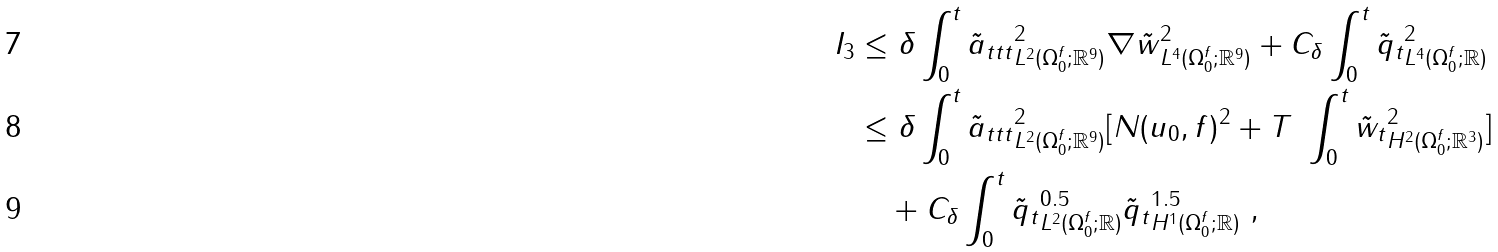Convert formula to latex. <formula><loc_0><loc_0><loc_500><loc_500>I _ { 3 } & \leq \delta \int _ { 0 } ^ { t } \| \tilde { a } _ { t t t } \| ^ { 2 } _ { L ^ { 2 } ( \Omega _ { 0 } ^ { f } ; { \mathbb { R } } ^ { 9 } ) } \| \nabla \tilde { w } \| ^ { 2 } _ { L ^ { 4 } ( \Omega _ { 0 } ^ { f } ; { \mathbb { R } } ^ { 9 } ) } + C _ { \delta } \int _ { 0 } ^ { t } \| \tilde { q } _ { t } \| ^ { 2 } _ { L ^ { 4 } ( \Omega _ { 0 } ^ { f } ; { \mathbb { R } } ) } \\ & \leq \delta \int _ { 0 } ^ { t } \| \tilde { a } _ { t t t } \| ^ { 2 } _ { L ^ { 2 } ( \Omega _ { 0 } ^ { f } ; { \mathbb { R } } ^ { 9 } ) } [ N ( u _ { 0 } , f ) ^ { 2 } + T \ \int _ { 0 } ^ { t } \| \tilde { w } _ { t } \| ^ { 2 } _ { H ^ { 2 } ( \Omega _ { 0 } ^ { f } ; { \mathbb { R } } ^ { 3 } ) } ] \\ & \quad + C _ { \delta } \int _ { 0 } ^ { t } \| \tilde { q } _ { t } \| ^ { 0 . 5 } _ { L ^ { 2 } ( \Omega _ { 0 } ^ { f } ; { \mathbb { R } } ) } \| \tilde { q } _ { t } \| ^ { 1 . 5 } _ { H ^ { 1 } ( \Omega _ { 0 } ^ { f } ; { \mathbb { R } } ) } \ ,</formula> 